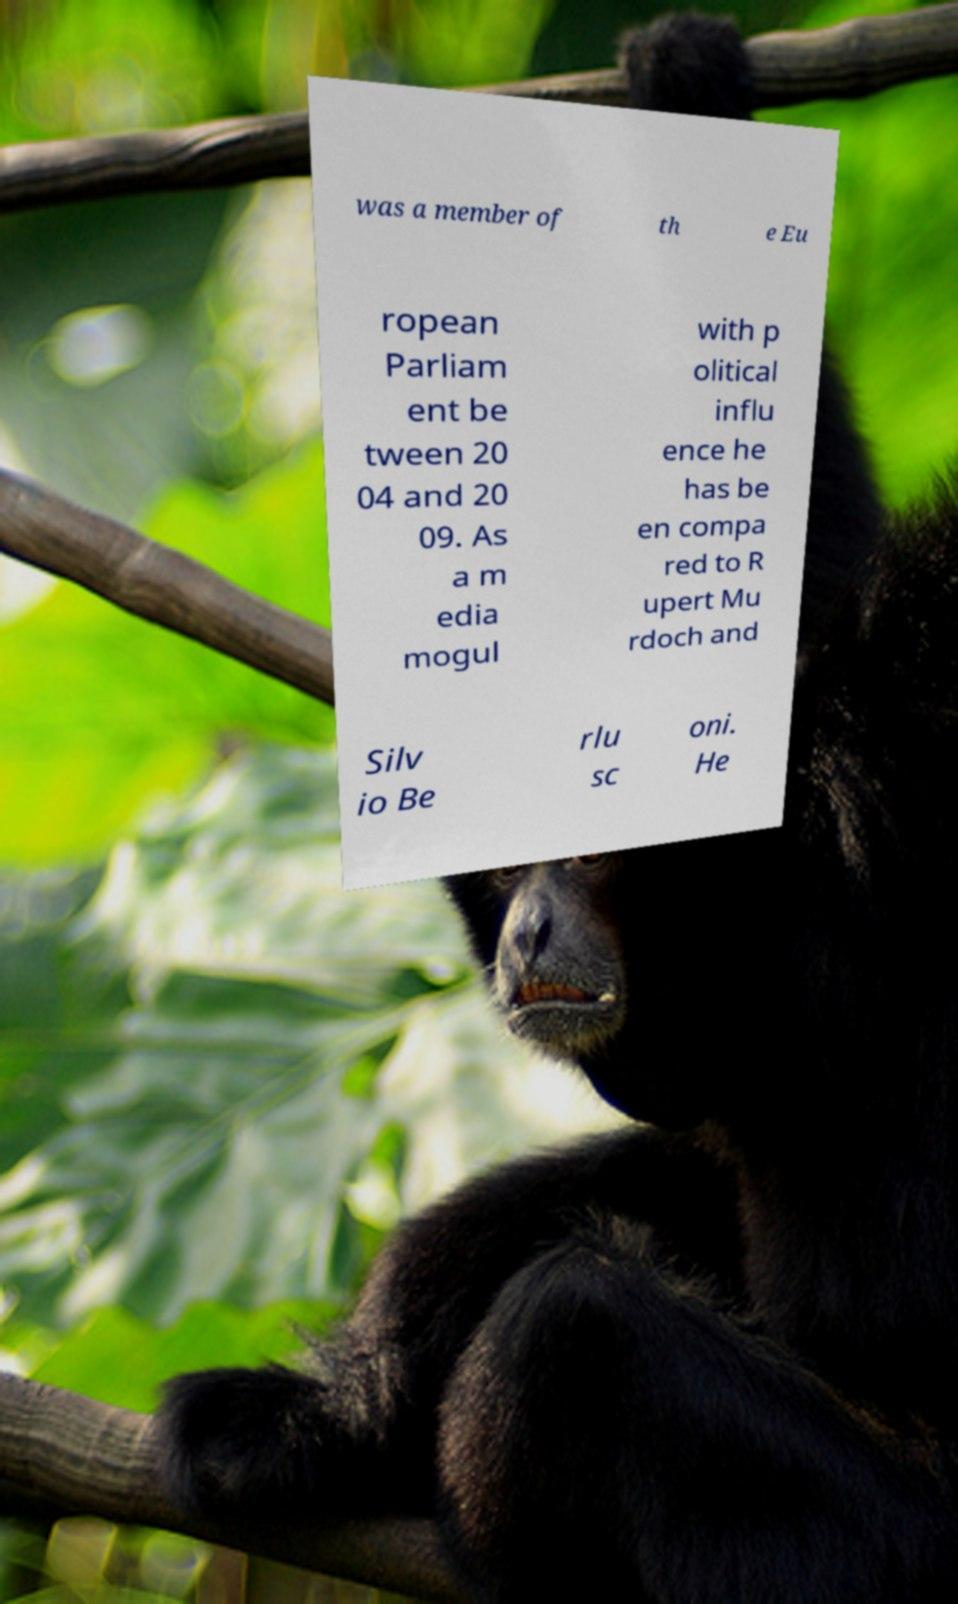I need the written content from this picture converted into text. Can you do that? was a member of th e Eu ropean Parliam ent be tween 20 04 and 20 09. As a m edia mogul with p olitical influ ence he has be en compa red to R upert Mu rdoch and Silv io Be rlu sc oni. He 